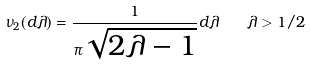<formula> <loc_0><loc_0><loc_500><loc_500>\nu _ { 2 } ( d \lambda ) = \frac { 1 } { \pi \sqrt { 2 \lambda - 1 } } d \lambda \quad \lambda > 1 / 2</formula> 